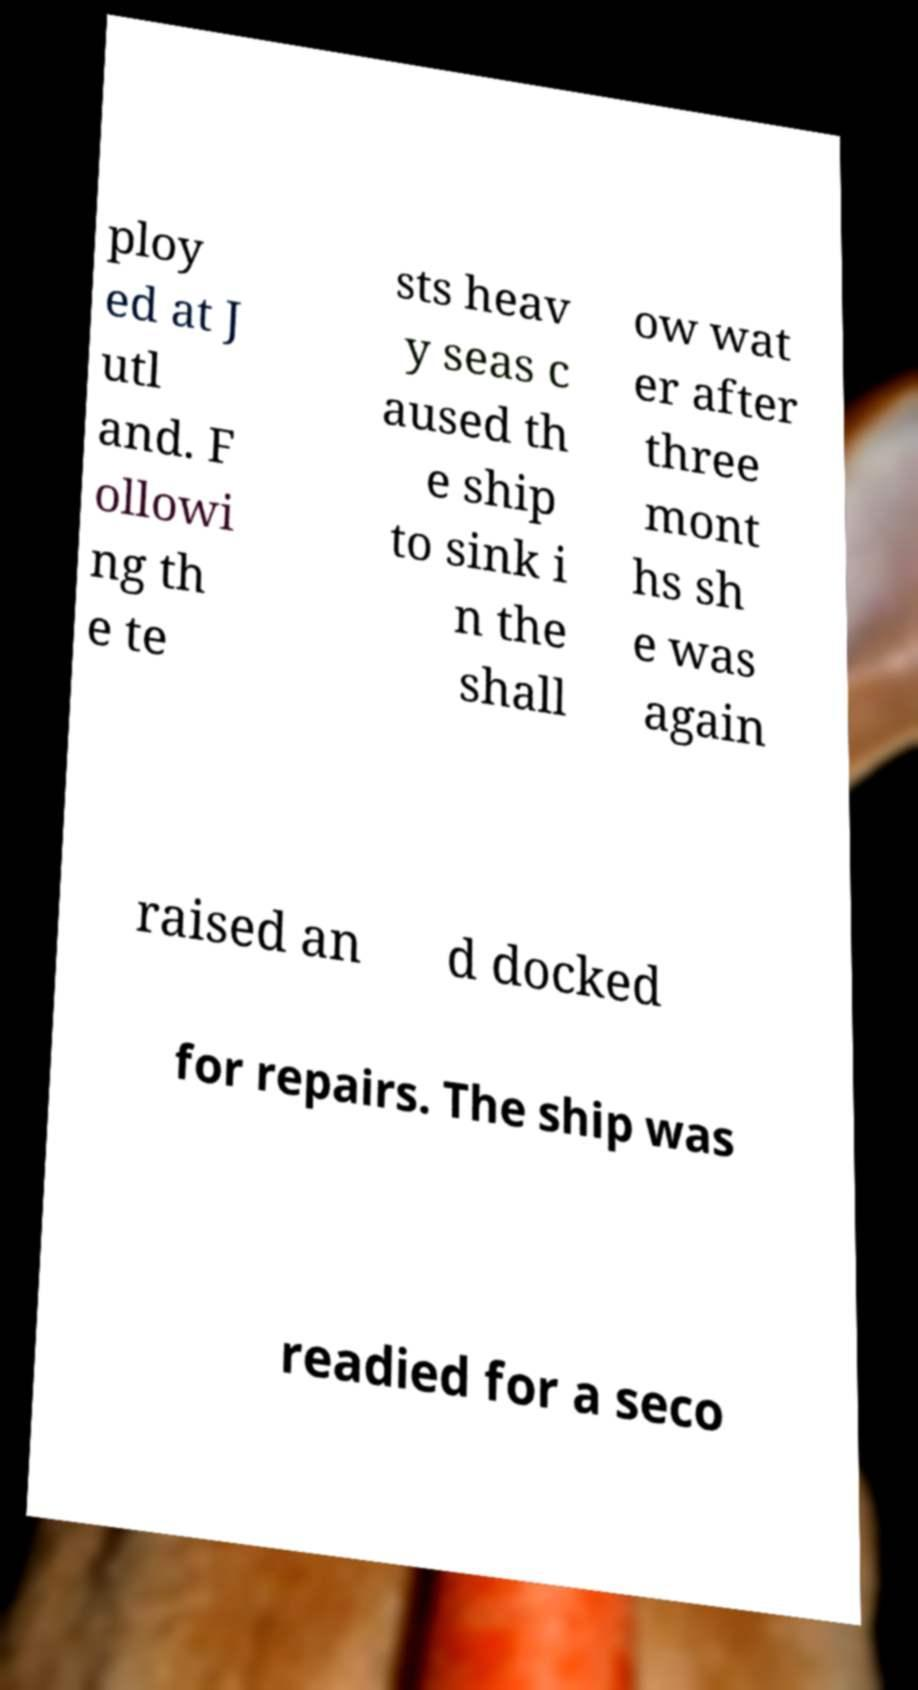Could you assist in decoding the text presented in this image and type it out clearly? ploy ed at J utl and. F ollowi ng th e te sts heav y seas c aused th e ship to sink i n the shall ow wat er after three mont hs sh e was again raised an d docked for repairs. The ship was readied for a seco 